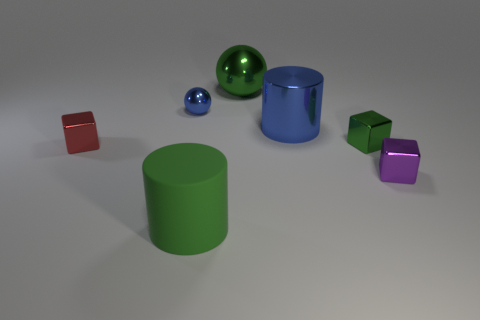Subtract 1 cubes. How many cubes are left? 2 Add 3 large green rubber cylinders. How many objects exist? 10 Subtract all spheres. How many objects are left? 5 Add 6 tiny balls. How many tiny balls exist? 7 Subtract 1 blue cylinders. How many objects are left? 6 Subtract all blocks. Subtract all tiny balls. How many objects are left? 3 Add 2 small blue spheres. How many small blue spheres are left? 3 